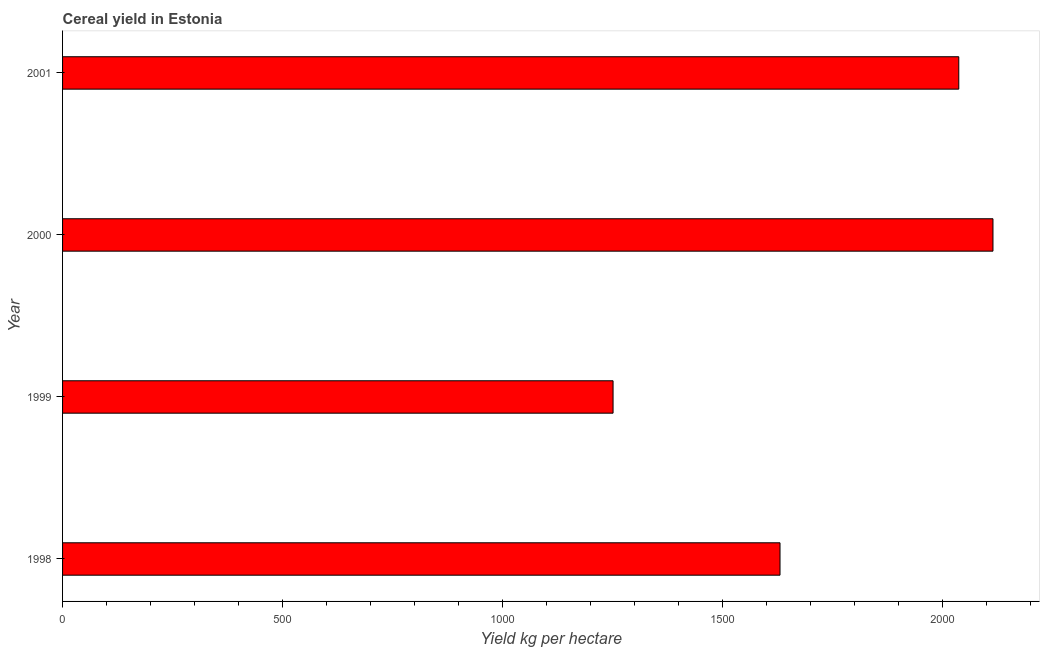Does the graph contain grids?
Your response must be concise. No. What is the title of the graph?
Keep it short and to the point. Cereal yield in Estonia. What is the label or title of the X-axis?
Make the answer very short. Yield kg per hectare. What is the cereal yield in 2000?
Provide a short and direct response. 2114.75. Across all years, what is the maximum cereal yield?
Offer a very short reply. 2114.75. Across all years, what is the minimum cereal yield?
Provide a succinct answer. 1251.26. In which year was the cereal yield minimum?
Provide a succinct answer. 1999. What is the sum of the cereal yield?
Offer a terse response. 7033.77. What is the difference between the cereal yield in 1998 and 2001?
Keep it short and to the point. -406.32. What is the average cereal yield per year?
Provide a succinct answer. 1758.44. What is the median cereal yield?
Your answer should be very brief. 1833.88. In how many years, is the cereal yield greater than 1700 kg per hectare?
Offer a very short reply. 2. Do a majority of the years between 1999 and 2000 (inclusive) have cereal yield greater than 1700 kg per hectare?
Keep it short and to the point. No. What is the ratio of the cereal yield in 2000 to that in 2001?
Provide a succinct answer. 1.04. What is the difference between the highest and the second highest cereal yield?
Your answer should be very brief. 77.7. Is the sum of the cereal yield in 1998 and 1999 greater than the maximum cereal yield across all years?
Offer a very short reply. Yes. What is the difference between the highest and the lowest cereal yield?
Your answer should be compact. 863.49. How many bars are there?
Offer a very short reply. 4. How many years are there in the graph?
Your answer should be compact. 4. What is the Yield kg per hectare in 1998?
Your answer should be compact. 1630.72. What is the Yield kg per hectare in 1999?
Offer a terse response. 1251.26. What is the Yield kg per hectare of 2000?
Your answer should be very brief. 2114.75. What is the Yield kg per hectare in 2001?
Ensure brevity in your answer.  2037.04. What is the difference between the Yield kg per hectare in 1998 and 1999?
Provide a succinct answer. 379.46. What is the difference between the Yield kg per hectare in 1998 and 2000?
Make the answer very short. -484.03. What is the difference between the Yield kg per hectare in 1998 and 2001?
Give a very brief answer. -406.32. What is the difference between the Yield kg per hectare in 1999 and 2000?
Your response must be concise. -863.49. What is the difference between the Yield kg per hectare in 1999 and 2001?
Your answer should be very brief. -785.79. What is the difference between the Yield kg per hectare in 2000 and 2001?
Provide a short and direct response. 77.7. What is the ratio of the Yield kg per hectare in 1998 to that in 1999?
Give a very brief answer. 1.3. What is the ratio of the Yield kg per hectare in 1998 to that in 2000?
Your response must be concise. 0.77. What is the ratio of the Yield kg per hectare in 1998 to that in 2001?
Offer a very short reply. 0.8. What is the ratio of the Yield kg per hectare in 1999 to that in 2000?
Ensure brevity in your answer.  0.59. What is the ratio of the Yield kg per hectare in 1999 to that in 2001?
Your response must be concise. 0.61. What is the ratio of the Yield kg per hectare in 2000 to that in 2001?
Keep it short and to the point. 1.04. 